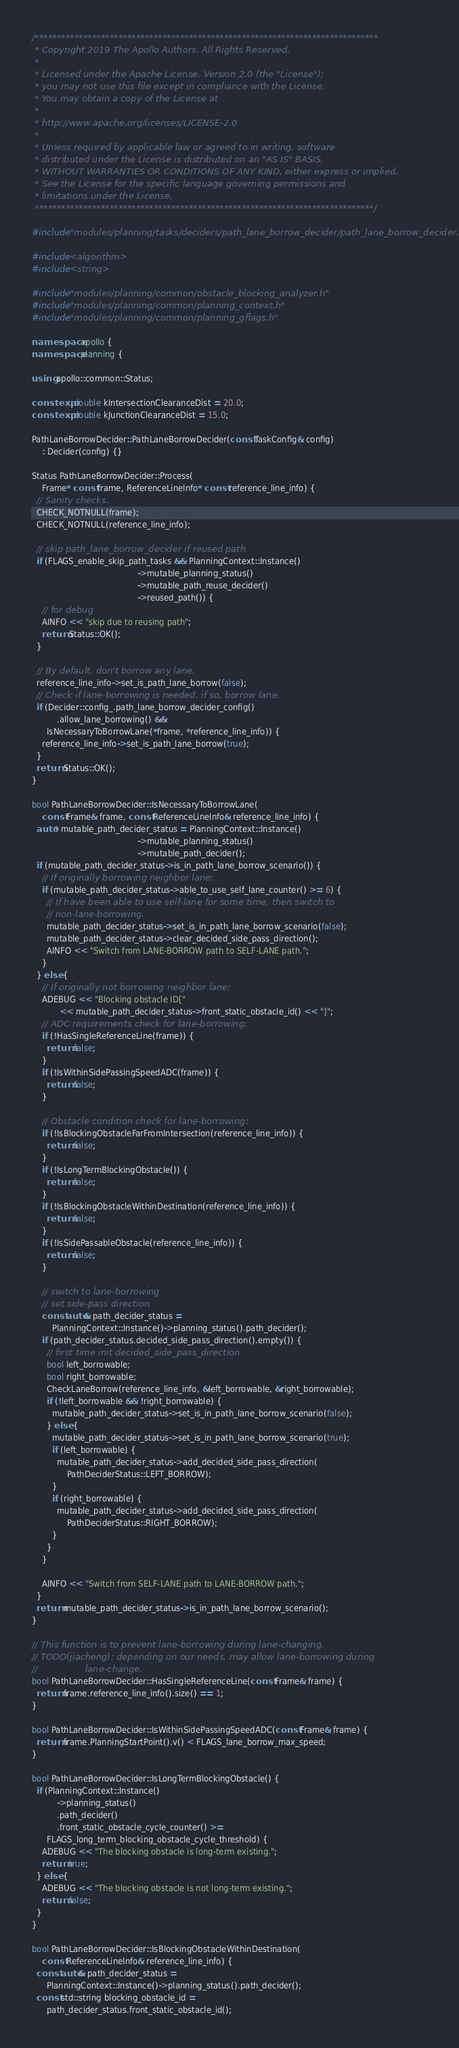<code> <loc_0><loc_0><loc_500><loc_500><_C++_>/******************************************************************************
 * Copyright 2019 The Apollo Authors. All Rights Reserved.
 *
 * Licensed under the Apache License, Version 2.0 (the "License");
 * you may not use this file except in compliance with the License.
 * You may obtain a copy of the License at
 *
 * http://www.apache.org/licenses/LICENSE-2.0
 *
 * Unless required by applicable law or agreed to in writing, software
 * distributed under the License is distributed on an "AS IS" BASIS,
 * WITHOUT WARRANTIES OR CONDITIONS OF ANY KIND, either express or implied.
 * See the License for the specific language governing permissions and
 * limitations under the License.
 *****************************************************************************/

#include "modules/planning/tasks/deciders/path_lane_borrow_decider/path_lane_borrow_decider.h"

#include <algorithm>
#include <string>

#include "modules/planning/common/obstacle_blocking_analyzer.h"
#include "modules/planning/common/planning_context.h"
#include "modules/planning/common/planning_gflags.h"

namespace apollo {
namespace planning {

using apollo::common::Status;

constexpr double kIntersectionClearanceDist = 20.0;
constexpr double kJunctionClearanceDist = 15.0;

PathLaneBorrowDecider::PathLaneBorrowDecider(const TaskConfig& config)
    : Decider(config) {}

Status PathLaneBorrowDecider::Process(
    Frame* const frame, ReferenceLineInfo* const reference_line_info) {
  // Sanity checks.
  CHECK_NOTNULL(frame);
  CHECK_NOTNULL(reference_line_info);

  // skip path_lane_borrow_decider if reused path
  if (FLAGS_enable_skip_path_tasks && PlanningContext::Instance()
                                          ->mutable_planning_status()
                                          ->mutable_path_reuse_decider()
                                          ->reused_path()) {
    // for debug
    AINFO << "skip due to reusing path";
    return Status::OK();
  }

  // By default, don't borrow any lane.
  reference_line_info->set_is_path_lane_borrow(false);
  // Check if lane-borrowing is needed, if so, borrow lane.
  if (Decider::config_.path_lane_borrow_decider_config()
          .allow_lane_borrowing() &&
      IsNecessaryToBorrowLane(*frame, *reference_line_info)) {
    reference_line_info->set_is_path_lane_borrow(true);
  }
  return Status::OK();
}

bool PathLaneBorrowDecider::IsNecessaryToBorrowLane(
    const Frame& frame, const ReferenceLineInfo& reference_line_info) {
  auto* mutable_path_decider_status = PlanningContext::Instance()
                                          ->mutable_planning_status()
                                          ->mutable_path_decider();
  if (mutable_path_decider_status->is_in_path_lane_borrow_scenario()) {
    // If originally borrowing neighbor lane:
    if (mutable_path_decider_status->able_to_use_self_lane_counter() >= 6) {
      // If have been able to use self-lane for some time, then switch to
      // non-lane-borrowing.
      mutable_path_decider_status->set_is_in_path_lane_borrow_scenario(false);
      mutable_path_decider_status->clear_decided_side_pass_direction();
      AINFO << "Switch from LANE-BORROW path to SELF-LANE path.";
    }
  } else {
    // If originally not borrowing neighbor lane:
    ADEBUG << "Blocking obstacle ID["
           << mutable_path_decider_status->front_static_obstacle_id() << "]";
    // ADC requirements check for lane-borrowing:
    if (!HasSingleReferenceLine(frame)) {
      return false;
    }
    if (!IsWithinSidePassingSpeedADC(frame)) {
      return false;
    }

    // Obstacle condition check for lane-borrowing:
    if (!IsBlockingObstacleFarFromIntersection(reference_line_info)) {
      return false;
    }
    if (!IsLongTermBlockingObstacle()) {
      return false;
    }
    if (!IsBlockingObstacleWithinDestination(reference_line_info)) {
      return false;
    }
    if (!IsSidePassableObstacle(reference_line_info)) {
      return false;
    }

    // switch to lane-borrowing
    // set side-pass direction
    const auto& path_decider_status =
        PlanningContext::Instance()->planning_status().path_decider();
    if (path_decider_status.decided_side_pass_direction().empty()) {
      // first time init decided_side_pass_direction
      bool left_borrowable;
      bool right_borrowable;
      CheckLaneBorrow(reference_line_info, &left_borrowable, &right_borrowable);
      if (!left_borrowable && !right_borrowable) {
        mutable_path_decider_status->set_is_in_path_lane_borrow_scenario(false);
      } else {
        mutable_path_decider_status->set_is_in_path_lane_borrow_scenario(true);
        if (left_borrowable) {
          mutable_path_decider_status->add_decided_side_pass_direction(
              PathDeciderStatus::LEFT_BORROW);
        }
        if (right_borrowable) {
          mutable_path_decider_status->add_decided_side_pass_direction(
              PathDeciderStatus::RIGHT_BORROW);
        }
      }
    }

    AINFO << "Switch from SELF-LANE path to LANE-BORROW path.";
  }
  return mutable_path_decider_status->is_in_path_lane_borrow_scenario();
}

// This function is to prevent lane-borrowing during lane-changing.
// TODO(jiacheng): depending on our needs, may allow lane-borrowing during
//                 lane-change.
bool PathLaneBorrowDecider::HasSingleReferenceLine(const Frame& frame) {
  return frame.reference_line_info().size() == 1;
}

bool PathLaneBorrowDecider::IsWithinSidePassingSpeedADC(const Frame& frame) {
  return frame.PlanningStartPoint().v() < FLAGS_lane_borrow_max_speed;
}

bool PathLaneBorrowDecider::IsLongTermBlockingObstacle() {
  if (PlanningContext::Instance()
          ->planning_status()
          .path_decider()
          .front_static_obstacle_cycle_counter() >=
      FLAGS_long_term_blocking_obstacle_cycle_threshold) {
    ADEBUG << "The blocking obstacle is long-term existing.";
    return true;
  } else {
    ADEBUG << "The blocking obstacle is not long-term existing.";
    return false;
  }
}

bool PathLaneBorrowDecider::IsBlockingObstacleWithinDestination(
    const ReferenceLineInfo& reference_line_info) {
  const auto& path_decider_status =
      PlanningContext::Instance()->planning_status().path_decider();
  const std::string blocking_obstacle_id =
      path_decider_status.front_static_obstacle_id();</code> 